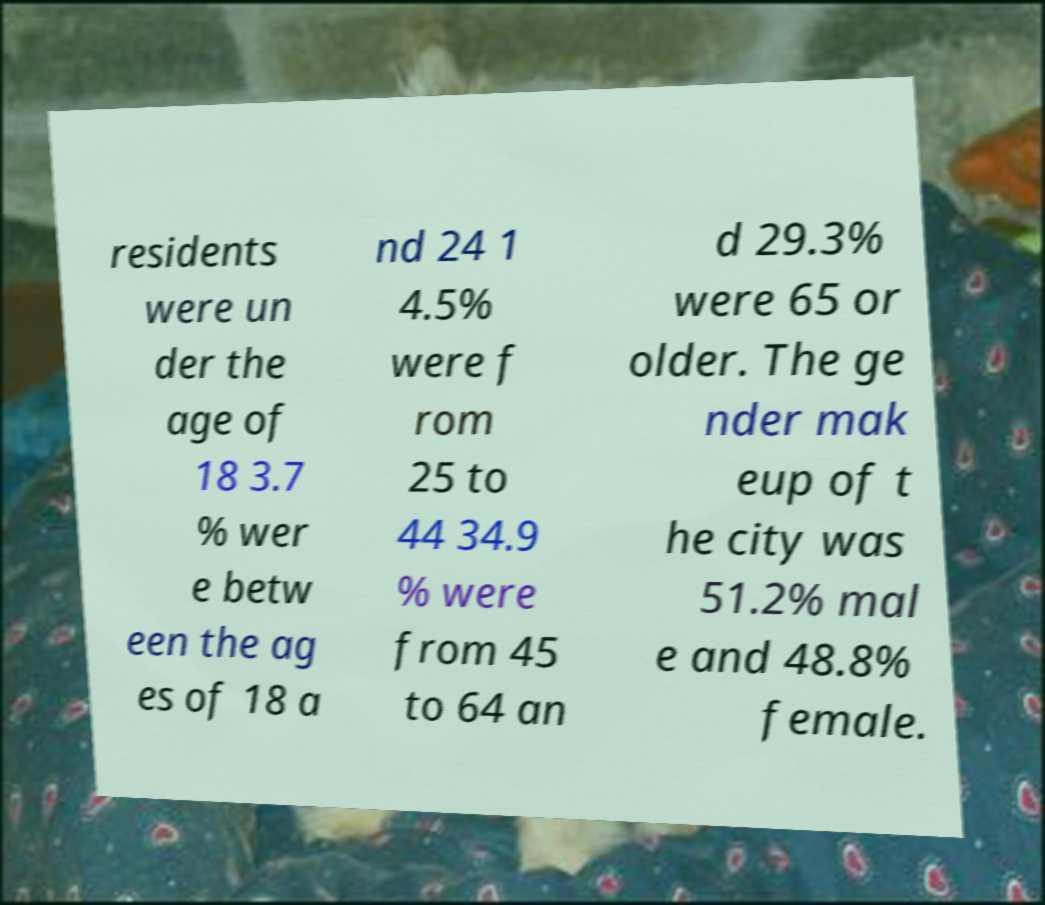What messages or text are displayed in this image? I need them in a readable, typed format. residents were un der the age of 18 3.7 % wer e betw een the ag es of 18 a nd 24 1 4.5% were f rom 25 to 44 34.9 % were from 45 to 64 an d 29.3% were 65 or older. The ge nder mak eup of t he city was 51.2% mal e and 48.8% female. 